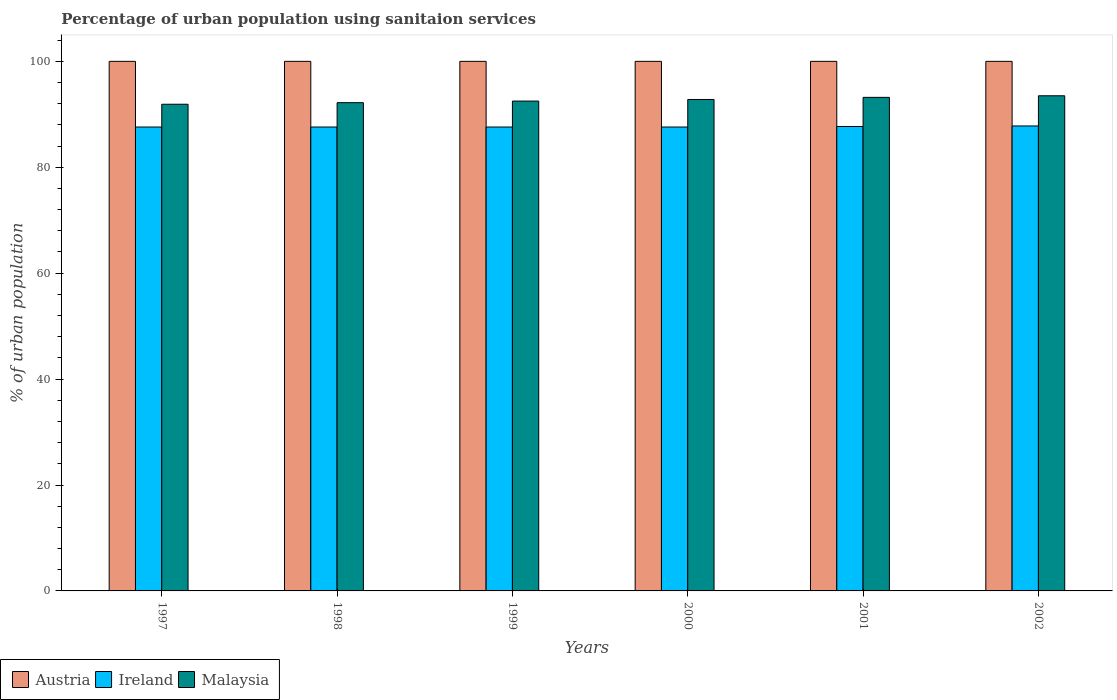How many different coloured bars are there?
Provide a succinct answer. 3. How many bars are there on the 4th tick from the left?
Ensure brevity in your answer.  3. How many bars are there on the 4th tick from the right?
Offer a terse response. 3. What is the percentage of urban population using sanitaion services in Ireland in 1999?
Offer a very short reply. 87.6. Across all years, what is the maximum percentage of urban population using sanitaion services in Austria?
Offer a very short reply. 100. Across all years, what is the minimum percentage of urban population using sanitaion services in Austria?
Ensure brevity in your answer.  100. In which year was the percentage of urban population using sanitaion services in Austria maximum?
Offer a very short reply. 1997. In which year was the percentage of urban population using sanitaion services in Ireland minimum?
Make the answer very short. 1997. What is the total percentage of urban population using sanitaion services in Ireland in the graph?
Offer a terse response. 525.9. What is the difference between the percentage of urban population using sanitaion services in Malaysia in 1997 and that in 2000?
Your answer should be very brief. -0.9. What is the average percentage of urban population using sanitaion services in Ireland per year?
Offer a terse response. 87.65. In the year 2000, what is the difference between the percentage of urban population using sanitaion services in Malaysia and percentage of urban population using sanitaion services in Austria?
Ensure brevity in your answer.  -7.2. What is the ratio of the percentage of urban population using sanitaion services in Austria in 1998 to that in 2002?
Your answer should be compact. 1. Is the percentage of urban population using sanitaion services in Austria in 1997 less than that in 1998?
Provide a short and direct response. No. What is the difference between the highest and the lowest percentage of urban population using sanitaion services in Austria?
Give a very brief answer. 0. What does the 3rd bar from the left in 2000 represents?
Make the answer very short. Malaysia. Is it the case that in every year, the sum of the percentage of urban population using sanitaion services in Ireland and percentage of urban population using sanitaion services in Austria is greater than the percentage of urban population using sanitaion services in Malaysia?
Give a very brief answer. Yes. What is the difference between two consecutive major ticks on the Y-axis?
Make the answer very short. 20. Are the values on the major ticks of Y-axis written in scientific E-notation?
Ensure brevity in your answer.  No. Does the graph contain grids?
Your response must be concise. No. Where does the legend appear in the graph?
Provide a succinct answer. Bottom left. How many legend labels are there?
Give a very brief answer. 3. What is the title of the graph?
Offer a terse response. Percentage of urban population using sanitaion services. What is the label or title of the X-axis?
Provide a short and direct response. Years. What is the label or title of the Y-axis?
Provide a succinct answer. % of urban population. What is the % of urban population in Austria in 1997?
Make the answer very short. 100. What is the % of urban population in Ireland in 1997?
Your response must be concise. 87.6. What is the % of urban population in Malaysia in 1997?
Give a very brief answer. 91.9. What is the % of urban population in Ireland in 1998?
Offer a terse response. 87.6. What is the % of urban population of Malaysia in 1998?
Make the answer very short. 92.2. What is the % of urban population in Ireland in 1999?
Make the answer very short. 87.6. What is the % of urban population in Malaysia in 1999?
Your answer should be compact. 92.5. What is the % of urban population of Ireland in 2000?
Give a very brief answer. 87.6. What is the % of urban population of Malaysia in 2000?
Provide a short and direct response. 92.8. What is the % of urban population in Ireland in 2001?
Provide a succinct answer. 87.7. What is the % of urban population in Malaysia in 2001?
Your answer should be very brief. 93.2. What is the % of urban population in Austria in 2002?
Your response must be concise. 100. What is the % of urban population in Ireland in 2002?
Your response must be concise. 87.8. What is the % of urban population of Malaysia in 2002?
Give a very brief answer. 93.5. Across all years, what is the maximum % of urban population of Ireland?
Your answer should be compact. 87.8. Across all years, what is the maximum % of urban population in Malaysia?
Your answer should be compact. 93.5. Across all years, what is the minimum % of urban population in Ireland?
Ensure brevity in your answer.  87.6. Across all years, what is the minimum % of urban population of Malaysia?
Your answer should be compact. 91.9. What is the total % of urban population in Austria in the graph?
Ensure brevity in your answer.  600. What is the total % of urban population of Ireland in the graph?
Offer a very short reply. 525.9. What is the total % of urban population of Malaysia in the graph?
Your response must be concise. 556.1. What is the difference between the % of urban population of Ireland in 1997 and that in 1998?
Provide a succinct answer. 0. What is the difference between the % of urban population of Austria in 1997 and that in 1999?
Make the answer very short. 0. What is the difference between the % of urban population in Ireland in 1997 and that in 1999?
Your response must be concise. 0. What is the difference between the % of urban population of Austria in 1997 and that in 2000?
Make the answer very short. 0. What is the difference between the % of urban population of Ireland in 1997 and that in 2000?
Offer a terse response. 0. What is the difference between the % of urban population of Austria in 1997 and that in 2001?
Provide a short and direct response. 0. What is the difference between the % of urban population of Austria in 1997 and that in 2002?
Ensure brevity in your answer.  0. What is the difference between the % of urban population of Austria in 1998 and that in 1999?
Provide a short and direct response. 0. What is the difference between the % of urban population of Ireland in 1998 and that in 1999?
Provide a succinct answer. 0. What is the difference between the % of urban population of Malaysia in 1998 and that in 2000?
Provide a short and direct response. -0.6. What is the difference between the % of urban population of Austria in 1998 and that in 2002?
Your answer should be very brief. 0. What is the difference between the % of urban population of Ireland in 1998 and that in 2002?
Your response must be concise. -0.2. What is the difference between the % of urban population of Austria in 1999 and that in 2000?
Give a very brief answer. 0. What is the difference between the % of urban population of Malaysia in 1999 and that in 2000?
Keep it short and to the point. -0.3. What is the difference between the % of urban population of Ireland in 1999 and that in 2001?
Offer a terse response. -0.1. What is the difference between the % of urban population of Malaysia in 1999 and that in 2001?
Keep it short and to the point. -0.7. What is the difference between the % of urban population of Ireland in 2000 and that in 2001?
Your answer should be very brief. -0.1. What is the difference between the % of urban population of Malaysia in 2000 and that in 2001?
Make the answer very short. -0.4. What is the difference between the % of urban population in Ireland in 2000 and that in 2002?
Your answer should be compact. -0.2. What is the difference between the % of urban population of Austria in 2001 and that in 2002?
Provide a short and direct response. 0. What is the difference between the % of urban population in Austria in 1997 and the % of urban population in Ireland in 1998?
Your answer should be compact. 12.4. What is the difference between the % of urban population of Austria in 1997 and the % of urban population of Malaysia in 1998?
Provide a short and direct response. 7.8. What is the difference between the % of urban population in Ireland in 1997 and the % of urban population in Malaysia in 1998?
Keep it short and to the point. -4.6. What is the difference between the % of urban population of Austria in 1997 and the % of urban population of Ireland in 2000?
Provide a succinct answer. 12.4. What is the difference between the % of urban population in Ireland in 1997 and the % of urban population in Malaysia in 2000?
Ensure brevity in your answer.  -5.2. What is the difference between the % of urban population in Austria in 1997 and the % of urban population in Ireland in 2001?
Keep it short and to the point. 12.3. What is the difference between the % of urban population of Austria in 1997 and the % of urban population of Malaysia in 2002?
Provide a succinct answer. 6.5. What is the difference between the % of urban population in Ireland in 1997 and the % of urban population in Malaysia in 2002?
Your response must be concise. -5.9. What is the difference between the % of urban population of Austria in 1998 and the % of urban population of Malaysia in 1999?
Offer a terse response. 7.5. What is the difference between the % of urban population of Ireland in 1998 and the % of urban population of Malaysia in 1999?
Provide a succinct answer. -4.9. What is the difference between the % of urban population of Austria in 1998 and the % of urban population of Malaysia in 2000?
Give a very brief answer. 7.2. What is the difference between the % of urban population in Austria in 1998 and the % of urban population in Ireland in 2001?
Offer a terse response. 12.3. What is the difference between the % of urban population of Ireland in 1998 and the % of urban population of Malaysia in 2001?
Make the answer very short. -5.6. What is the difference between the % of urban population in Austria in 1998 and the % of urban population in Ireland in 2002?
Keep it short and to the point. 12.2. What is the difference between the % of urban population of Ireland in 1998 and the % of urban population of Malaysia in 2002?
Give a very brief answer. -5.9. What is the difference between the % of urban population of Austria in 1999 and the % of urban population of Ireland in 2000?
Your answer should be very brief. 12.4. What is the difference between the % of urban population in Austria in 1999 and the % of urban population in Malaysia in 2000?
Your response must be concise. 7.2. What is the difference between the % of urban population of Austria in 1999 and the % of urban population of Malaysia in 2001?
Ensure brevity in your answer.  6.8. What is the difference between the % of urban population in Austria in 2000 and the % of urban population in Malaysia in 2002?
Keep it short and to the point. 6.5. What is the average % of urban population in Ireland per year?
Give a very brief answer. 87.65. What is the average % of urban population in Malaysia per year?
Provide a succinct answer. 92.68. In the year 1997, what is the difference between the % of urban population in Austria and % of urban population in Ireland?
Your answer should be compact. 12.4. In the year 1998, what is the difference between the % of urban population in Austria and % of urban population in Malaysia?
Ensure brevity in your answer.  7.8. In the year 1999, what is the difference between the % of urban population of Austria and % of urban population of Malaysia?
Offer a terse response. 7.5. In the year 2000, what is the difference between the % of urban population in Austria and % of urban population in Ireland?
Your answer should be compact. 12.4. In the year 2000, what is the difference between the % of urban population of Austria and % of urban population of Malaysia?
Offer a terse response. 7.2. In the year 2001, what is the difference between the % of urban population of Austria and % of urban population of Malaysia?
Make the answer very short. 6.8. In the year 2002, what is the difference between the % of urban population in Austria and % of urban population in Malaysia?
Provide a short and direct response. 6.5. In the year 2002, what is the difference between the % of urban population in Ireland and % of urban population in Malaysia?
Keep it short and to the point. -5.7. What is the ratio of the % of urban population in Austria in 1997 to that in 1998?
Give a very brief answer. 1. What is the ratio of the % of urban population of Malaysia in 1997 to that in 1998?
Give a very brief answer. 1. What is the ratio of the % of urban population of Austria in 1997 to that in 1999?
Offer a very short reply. 1. What is the ratio of the % of urban population in Malaysia in 1997 to that in 1999?
Your answer should be compact. 0.99. What is the ratio of the % of urban population in Austria in 1997 to that in 2000?
Your response must be concise. 1. What is the ratio of the % of urban population in Ireland in 1997 to that in 2000?
Keep it short and to the point. 1. What is the ratio of the % of urban population in Malaysia in 1997 to that in 2000?
Give a very brief answer. 0.99. What is the ratio of the % of urban population in Austria in 1997 to that in 2001?
Your response must be concise. 1. What is the ratio of the % of urban population in Ireland in 1997 to that in 2001?
Offer a very short reply. 1. What is the ratio of the % of urban population of Malaysia in 1997 to that in 2001?
Offer a very short reply. 0.99. What is the ratio of the % of urban population in Malaysia in 1997 to that in 2002?
Provide a short and direct response. 0.98. What is the ratio of the % of urban population of Austria in 1998 to that in 1999?
Provide a succinct answer. 1. What is the ratio of the % of urban population of Malaysia in 1998 to that in 1999?
Your answer should be compact. 1. What is the ratio of the % of urban population in Ireland in 1998 to that in 2000?
Provide a succinct answer. 1. What is the ratio of the % of urban population in Ireland in 1998 to that in 2001?
Offer a very short reply. 1. What is the ratio of the % of urban population in Malaysia in 1998 to that in 2001?
Offer a terse response. 0.99. What is the ratio of the % of urban population in Malaysia in 1998 to that in 2002?
Provide a short and direct response. 0.99. What is the ratio of the % of urban population of Ireland in 1999 to that in 2000?
Make the answer very short. 1. What is the ratio of the % of urban population in Malaysia in 1999 to that in 2000?
Your answer should be compact. 1. What is the ratio of the % of urban population of Austria in 1999 to that in 2001?
Offer a terse response. 1. What is the ratio of the % of urban population in Ireland in 1999 to that in 2001?
Offer a very short reply. 1. What is the ratio of the % of urban population in Malaysia in 1999 to that in 2001?
Your answer should be very brief. 0.99. What is the ratio of the % of urban population in Austria in 1999 to that in 2002?
Provide a succinct answer. 1. What is the ratio of the % of urban population in Ireland in 1999 to that in 2002?
Provide a short and direct response. 1. What is the ratio of the % of urban population of Malaysia in 1999 to that in 2002?
Provide a short and direct response. 0.99. What is the ratio of the % of urban population in Ireland in 2000 to that in 2002?
Your answer should be very brief. 1. What is the ratio of the % of urban population of Ireland in 2001 to that in 2002?
Offer a terse response. 1. What is the ratio of the % of urban population of Malaysia in 2001 to that in 2002?
Offer a very short reply. 1. What is the difference between the highest and the second highest % of urban population of Austria?
Keep it short and to the point. 0. What is the difference between the highest and the lowest % of urban population in Austria?
Provide a succinct answer. 0. What is the difference between the highest and the lowest % of urban population of Ireland?
Ensure brevity in your answer.  0.2. What is the difference between the highest and the lowest % of urban population in Malaysia?
Make the answer very short. 1.6. 